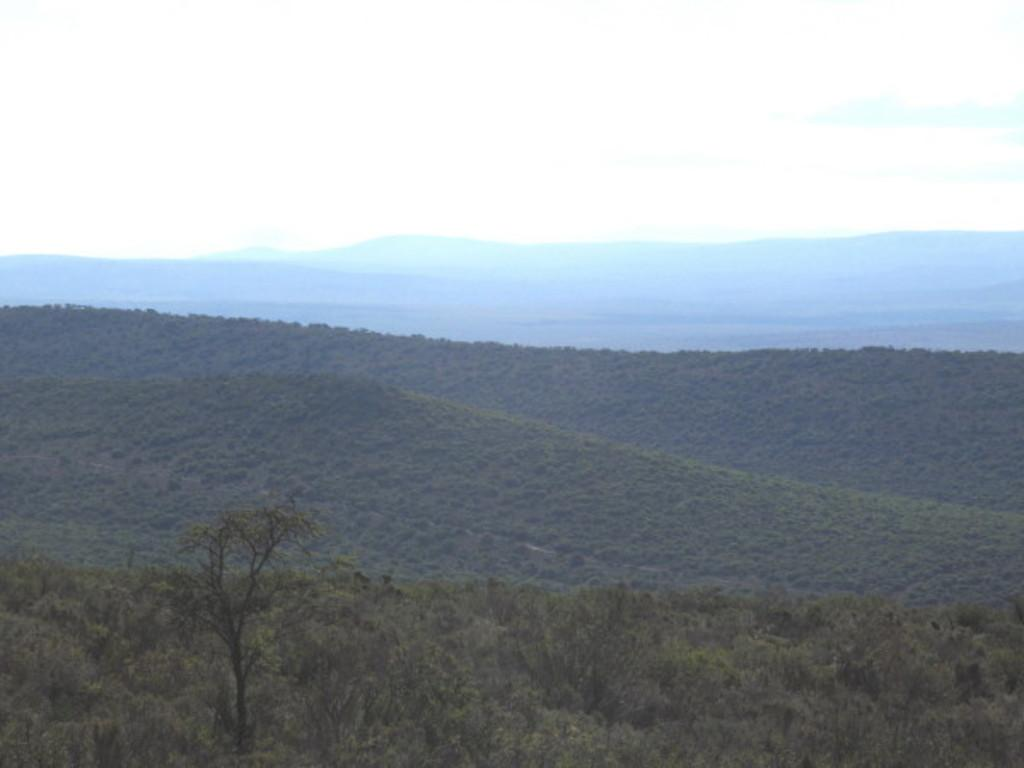What type of natural landform can be seen in the image? There are mountains in the image. What type of vegetation is present in the image? There are trees in the image. What part of the natural environment is visible in the image? The sky is visible in the image. Can you tell me how many toads are sitting on the mountains in the image? There are no toads present in the image; it features mountains and trees. What type of muscle is visible in the image? There is no muscle visible in the image, as it features mountains, trees, and the sky. 